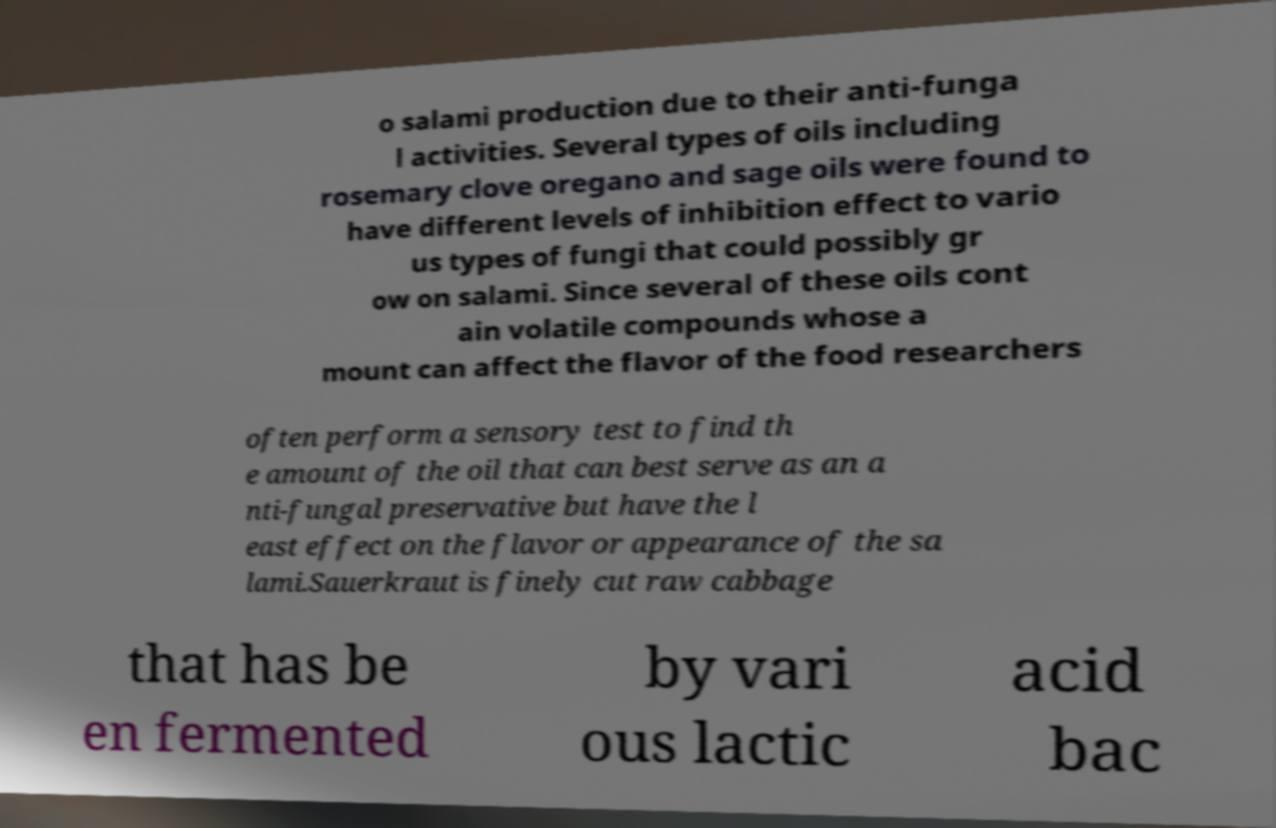For documentation purposes, I need the text within this image transcribed. Could you provide that? o salami production due to their anti-funga l activities. Several types of oils including rosemary clove oregano and sage oils were found to have different levels of inhibition effect to vario us types of fungi that could possibly gr ow on salami. Since several of these oils cont ain volatile compounds whose a mount can affect the flavor of the food researchers often perform a sensory test to find th e amount of the oil that can best serve as an a nti-fungal preservative but have the l east effect on the flavor or appearance of the sa lami.Sauerkraut is finely cut raw cabbage that has be en fermented by vari ous lactic acid bac 